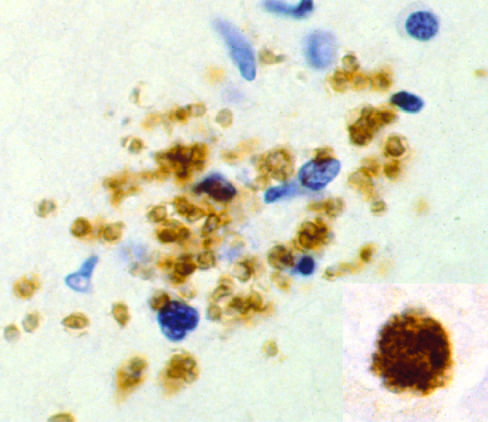what are present as a pseudocyst, again highlighted by immunohistochemical staining?
Answer the question using a single word or phrase. Bradyzoites 